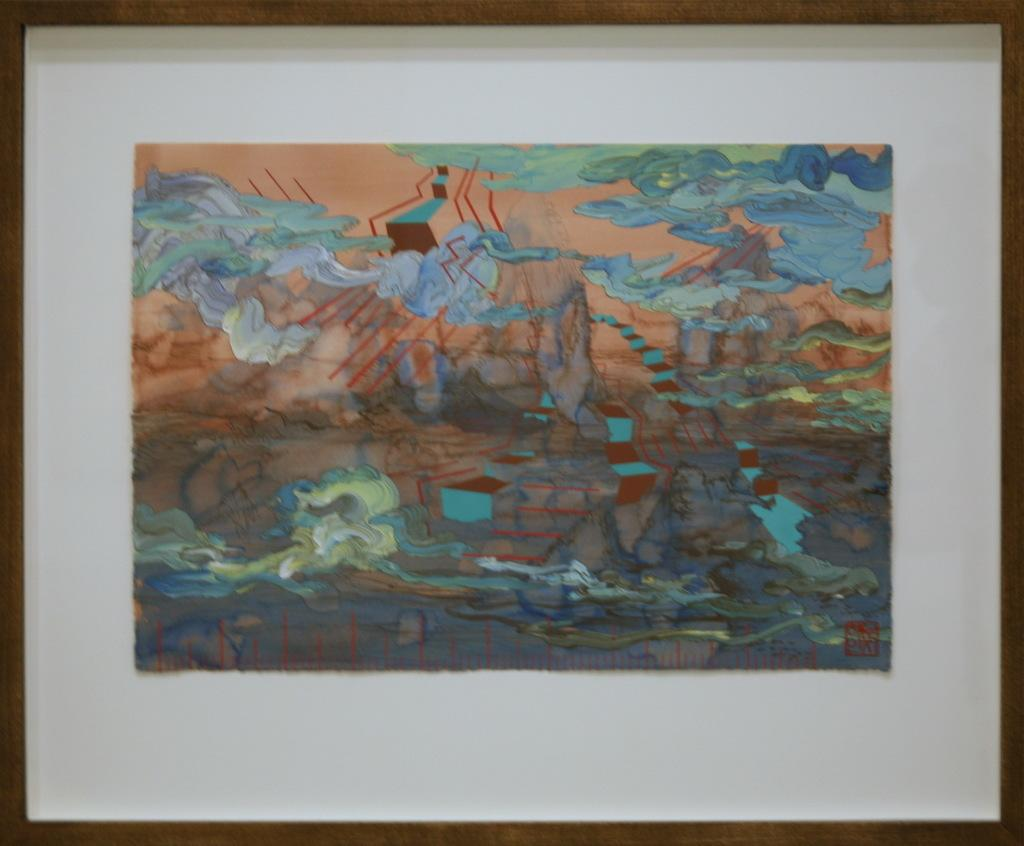What is one of the objects visible in the image? There is a photo frame in the image. What type of artwork can be seen in the image? There is a painting in the image. Can you see any icicles hanging from the photo frame in the image? There are no icicles visible in the image, as the photo frame is indoors and not exposed to cold temperatures. Is there a soda can placed next to the painting in the image? There is no mention of a soda can in the image, so it cannot be determined if one is present. 